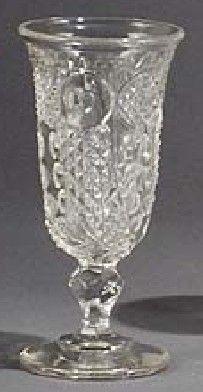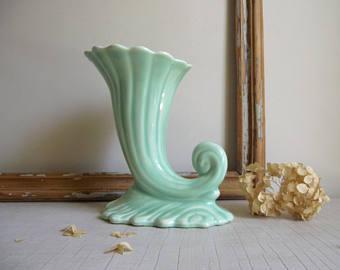The first image is the image on the left, the second image is the image on the right. Assess this claim about the two images: "An image shows a vase with a curl like an ocean wave at the bottom.". Correct or not? Answer yes or no. Yes. The first image is the image on the left, the second image is the image on the right. Examine the images to the left and right. Is the description "One of the goblets has a curled tail." accurate? Answer yes or no. Yes. 